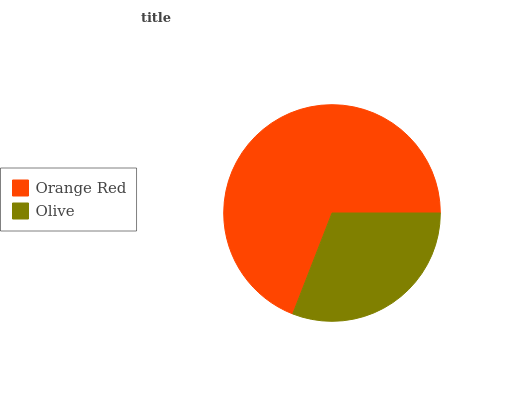Is Olive the minimum?
Answer yes or no. Yes. Is Orange Red the maximum?
Answer yes or no. Yes. Is Olive the maximum?
Answer yes or no. No. Is Orange Red greater than Olive?
Answer yes or no. Yes. Is Olive less than Orange Red?
Answer yes or no. Yes. Is Olive greater than Orange Red?
Answer yes or no. No. Is Orange Red less than Olive?
Answer yes or no. No. Is Orange Red the high median?
Answer yes or no. Yes. Is Olive the low median?
Answer yes or no. Yes. Is Olive the high median?
Answer yes or no. No. Is Orange Red the low median?
Answer yes or no. No. 